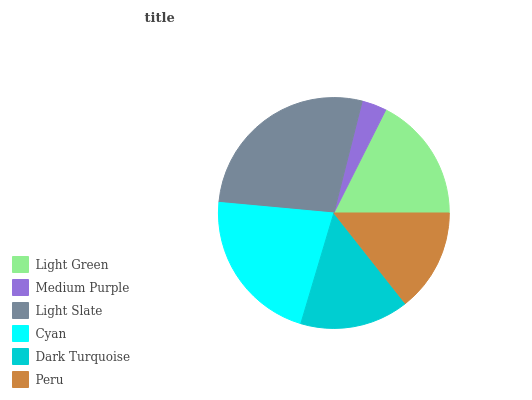Is Medium Purple the minimum?
Answer yes or no. Yes. Is Light Slate the maximum?
Answer yes or no. Yes. Is Light Slate the minimum?
Answer yes or no. No. Is Medium Purple the maximum?
Answer yes or no. No. Is Light Slate greater than Medium Purple?
Answer yes or no. Yes. Is Medium Purple less than Light Slate?
Answer yes or no. Yes. Is Medium Purple greater than Light Slate?
Answer yes or no. No. Is Light Slate less than Medium Purple?
Answer yes or no. No. Is Light Green the high median?
Answer yes or no. Yes. Is Dark Turquoise the low median?
Answer yes or no. Yes. Is Peru the high median?
Answer yes or no. No. Is Cyan the low median?
Answer yes or no. No. 